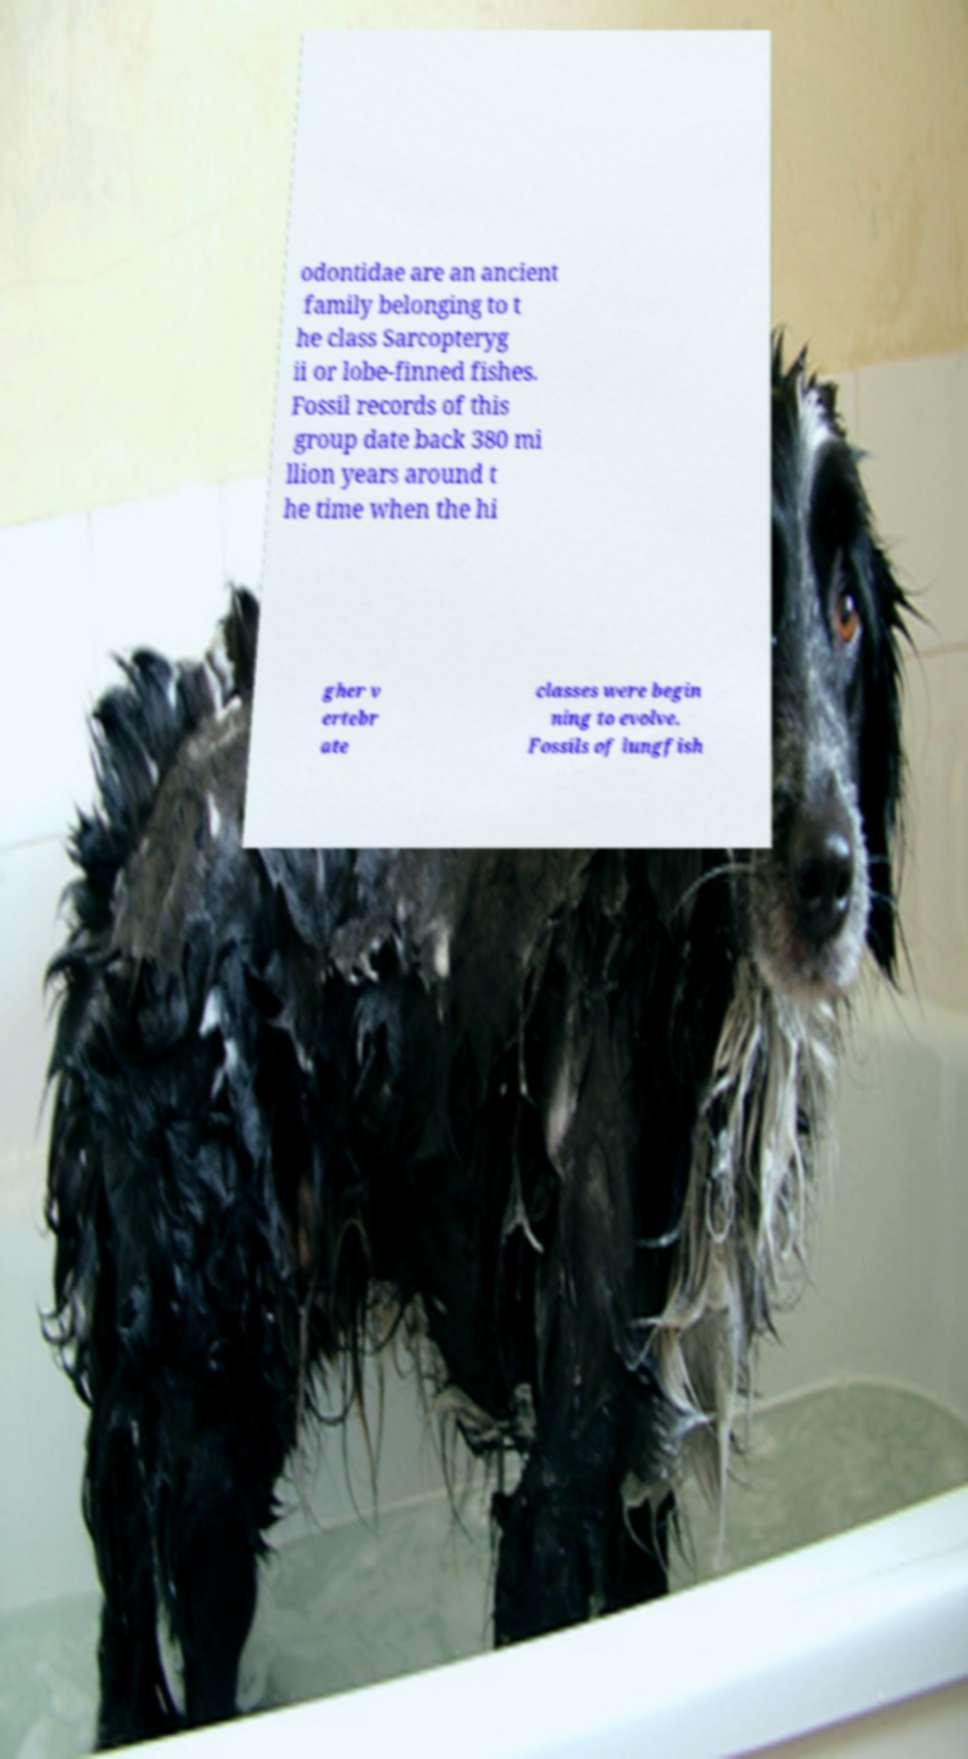Can you read and provide the text displayed in the image?This photo seems to have some interesting text. Can you extract and type it out for me? odontidae are an ancient family belonging to t he class Sarcopteryg ii or lobe-finned fishes. Fossil records of this group date back 380 mi llion years around t he time when the hi gher v ertebr ate classes were begin ning to evolve. Fossils of lungfish 